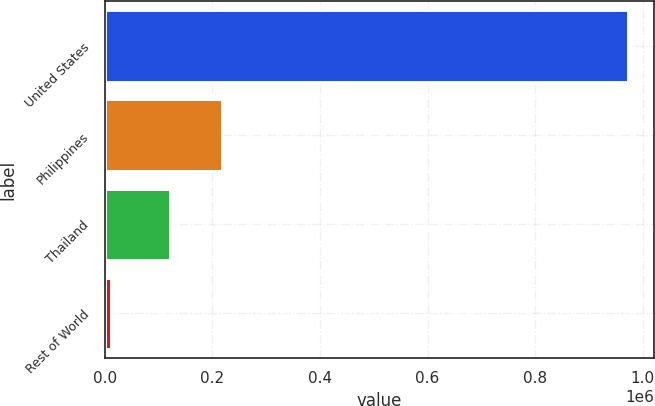<chart> <loc_0><loc_0><loc_500><loc_500><bar_chart><fcel>United States<fcel>Philippines<fcel>Thailand<fcel>Rest of World<nl><fcel>972380<fcel>216971<fcel>120838<fcel>11051<nl></chart> 